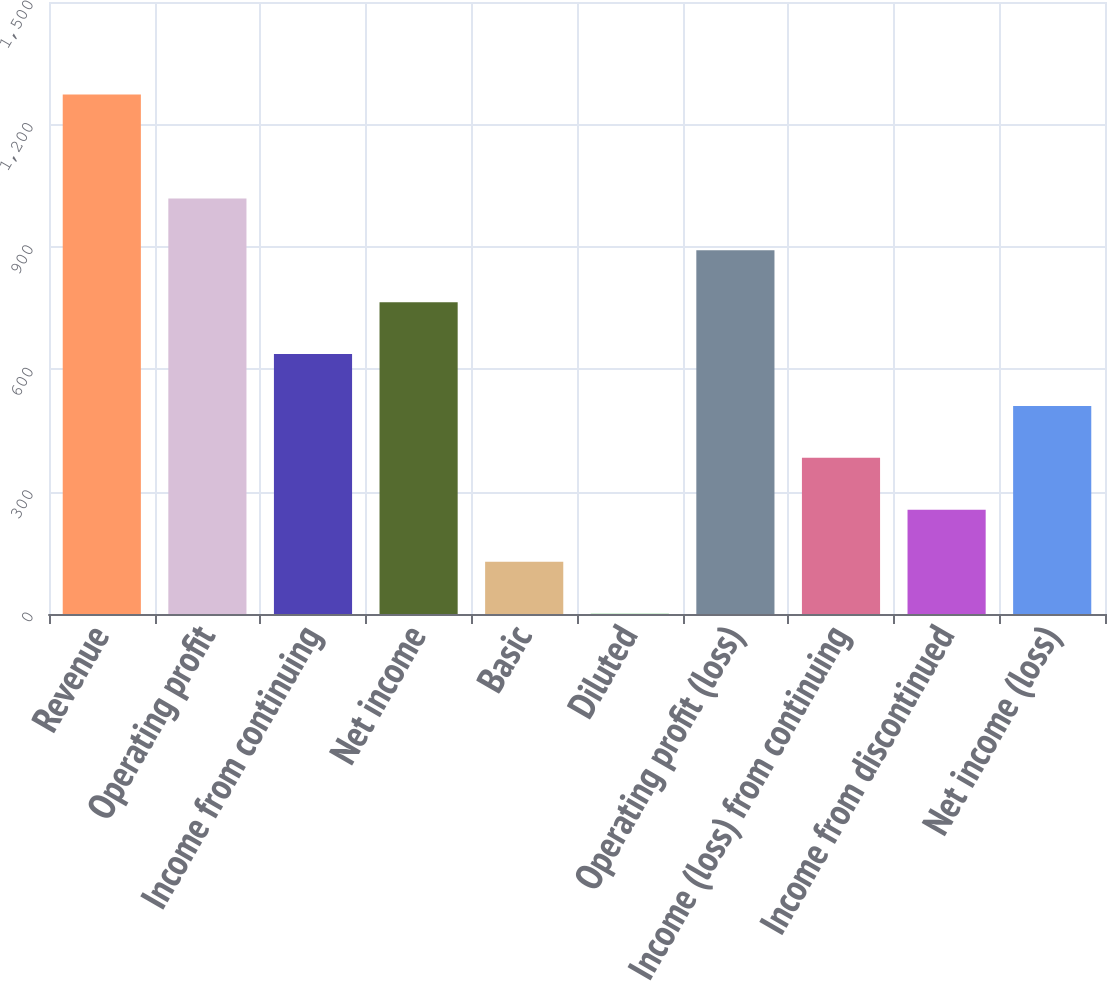Convert chart to OTSL. <chart><loc_0><loc_0><loc_500><loc_500><bar_chart><fcel>Revenue<fcel>Operating profit<fcel>Income from continuing<fcel>Net income<fcel>Basic<fcel>Diluted<fcel>Operating profit (loss)<fcel>Income (loss) from continuing<fcel>Income from discontinued<fcel>Net income (loss)<nl><fcel>1273<fcel>1018.62<fcel>637.05<fcel>764.24<fcel>128.29<fcel>1.1<fcel>891.43<fcel>382.67<fcel>255.48<fcel>509.86<nl></chart> 